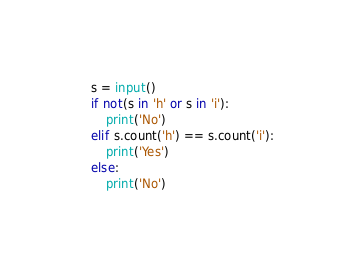Convert code to text. <code><loc_0><loc_0><loc_500><loc_500><_Python_>s = input()
if not(s in 'h' or s in 'i'):
    print('No')
elif s.count('h') == s.count('i'):
    print('Yes')
else:
    print('No')</code> 